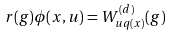<formula> <loc_0><loc_0><loc_500><loc_500>r ( g ) \phi ( x , u ) = W ^ { ( d ) } _ { u q ( x ) } ( g )</formula> 